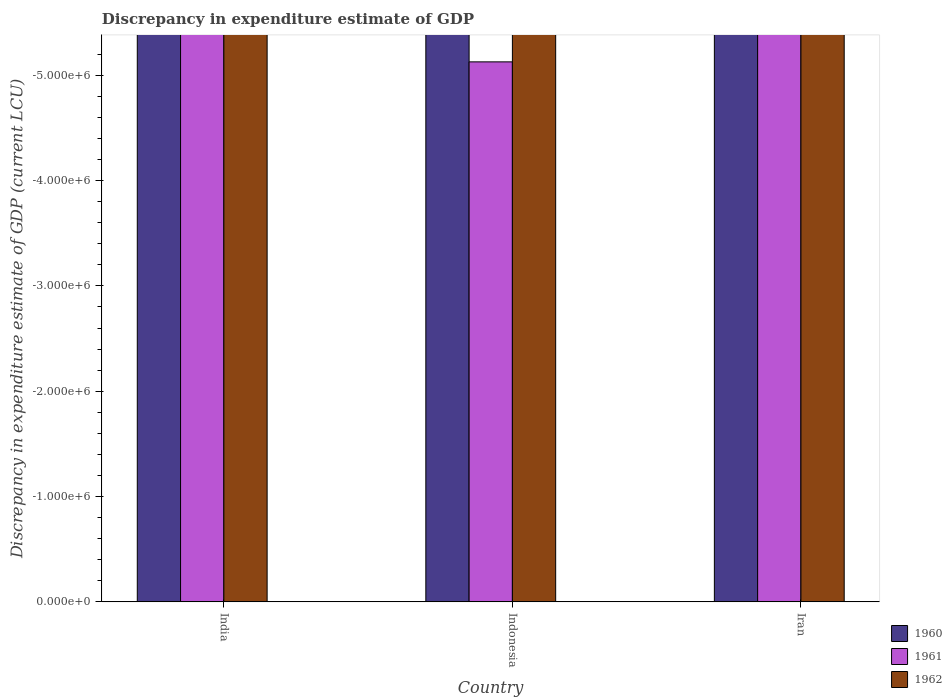How many bars are there on the 2nd tick from the left?
Your answer should be compact. 0. How many bars are there on the 2nd tick from the right?
Make the answer very short. 0. What is the label of the 3rd group of bars from the left?
Provide a short and direct response. Iran. Across all countries, what is the minimum discrepancy in expenditure estimate of GDP in 1962?
Offer a very short reply. 0. In how many countries, is the discrepancy in expenditure estimate of GDP in 1962 greater than -3600000 LCU?
Keep it short and to the point. 0. In how many countries, is the discrepancy in expenditure estimate of GDP in 1962 greater than the average discrepancy in expenditure estimate of GDP in 1962 taken over all countries?
Offer a terse response. 0. How many bars are there?
Provide a succinct answer. 0. Are all the bars in the graph horizontal?
Make the answer very short. No. Does the graph contain any zero values?
Offer a very short reply. Yes. What is the title of the graph?
Give a very brief answer. Discrepancy in expenditure estimate of GDP. Does "1971" appear as one of the legend labels in the graph?
Give a very brief answer. No. What is the label or title of the X-axis?
Give a very brief answer. Country. What is the label or title of the Y-axis?
Make the answer very short. Discrepancy in expenditure estimate of GDP (current LCU). What is the Discrepancy in expenditure estimate of GDP (current LCU) in 1962 in India?
Offer a terse response. 0. What is the Discrepancy in expenditure estimate of GDP (current LCU) in 1960 in Indonesia?
Give a very brief answer. 0. What is the Discrepancy in expenditure estimate of GDP (current LCU) in 1961 in Iran?
Your response must be concise. 0. What is the total Discrepancy in expenditure estimate of GDP (current LCU) of 1960 in the graph?
Give a very brief answer. 0. What is the total Discrepancy in expenditure estimate of GDP (current LCU) in 1961 in the graph?
Make the answer very short. 0. What is the total Discrepancy in expenditure estimate of GDP (current LCU) of 1962 in the graph?
Make the answer very short. 0. What is the average Discrepancy in expenditure estimate of GDP (current LCU) in 1960 per country?
Keep it short and to the point. 0. What is the average Discrepancy in expenditure estimate of GDP (current LCU) of 1962 per country?
Ensure brevity in your answer.  0. 